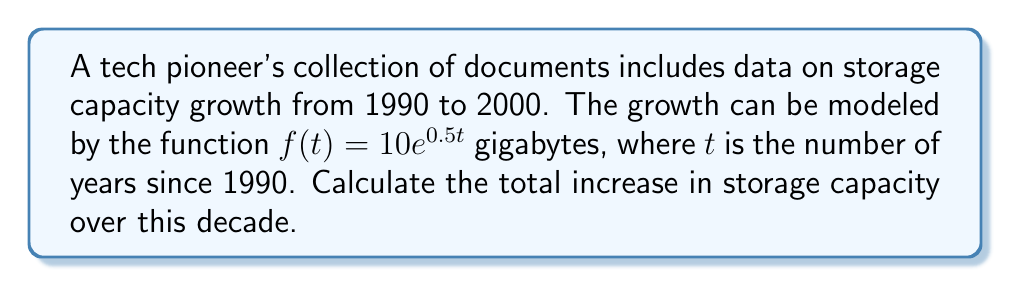Solve this math problem. To find the total increase in storage capacity, we need to calculate the area under the curve of $f(t)$ from $t=0$ to $t=10$.

1. Set up the definite integral:
   $$\int_{0}^{10} 10e^{0.5t} dt$$

2. Use the substitution method:
   Let $u = 0.5t$, then $du = 0.5dt$ or $dt = 2du$
   When $t=0$, $u=0$; when $t=10$, $u=5$

3. Rewrite the integral:
   $$20\int_{0}^{5} e^u du$$

4. Evaluate the integral:
   $$20[e^u]_{0}^{5} = 20(e^5 - e^0) = 20(e^5 - 1)$$

5. Calculate the final value:
   $$20(e^5 - 1) \approx 2980.96$$

The total increase in storage capacity over the decade is approximately 2980.96 gigabytes.
Answer: 2980.96 gigabytes 